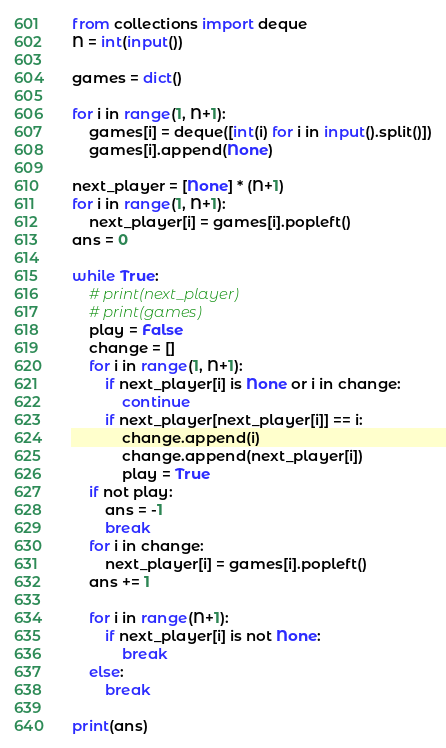<code> <loc_0><loc_0><loc_500><loc_500><_Python_>from collections import deque
N = int(input())

games = dict()

for i in range(1, N+1):
    games[i] = deque([int(i) for i in input().split()])
    games[i].append(None)

next_player = [None] * (N+1)
for i in range(1, N+1):
    next_player[i] = games[i].popleft()
ans = 0

while True:
    # print(next_player)
    # print(games)
    play = False
    change = []
    for i in range(1, N+1):
        if next_player[i] is None or i in change:
            continue
        if next_player[next_player[i]] == i:
            change.append(i)
            change.append(next_player[i])
            play = True
    if not play:
        ans = -1
        break
    for i in change:
        next_player[i] = games[i].popleft()
    ans += 1

    for i in range(N+1):
        if next_player[i] is not None:
            break
    else:
        break

print(ans)
</code> 